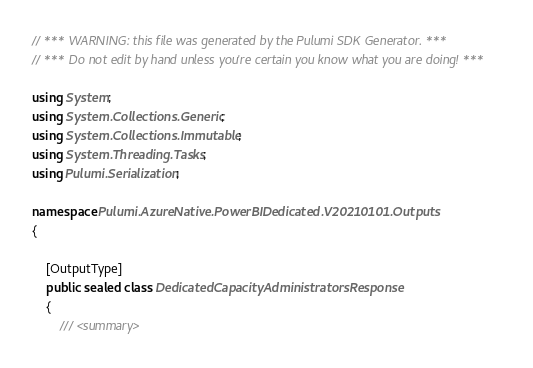Convert code to text. <code><loc_0><loc_0><loc_500><loc_500><_C#_>// *** WARNING: this file was generated by the Pulumi SDK Generator. ***
// *** Do not edit by hand unless you're certain you know what you are doing! ***

using System;
using System.Collections.Generic;
using System.Collections.Immutable;
using System.Threading.Tasks;
using Pulumi.Serialization;

namespace Pulumi.AzureNative.PowerBIDedicated.V20210101.Outputs
{

    [OutputType]
    public sealed class DedicatedCapacityAdministratorsResponse
    {
        /// <summary></code> 